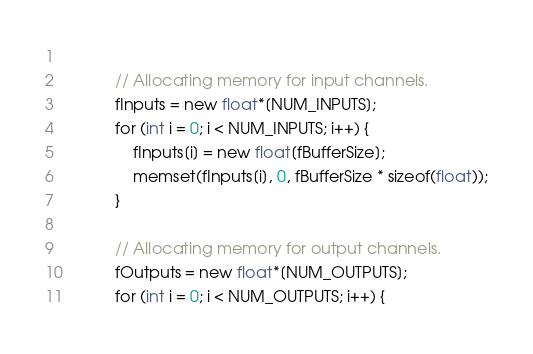Convert code to text. <code><loc_0><loc_0><loc_500><loc_500><_C_>            
            // Allocating memory for input channels.
            fInputs = new float*[NUM_INPUTS];
            for (int i = 0; i < NUM_INPUTS; i++) {
                fInputs[i] = new float[fBufferSize];
                memset(fInputs[i], 0, fBufferSize * sizeof(float));
            }
    
            // Allocating memory for output channels.
            fOutputs = new float*[NUM_OUTPUTS];
            for (int i = 0; i < NUM_OUTPUTS; i++) {</code> 